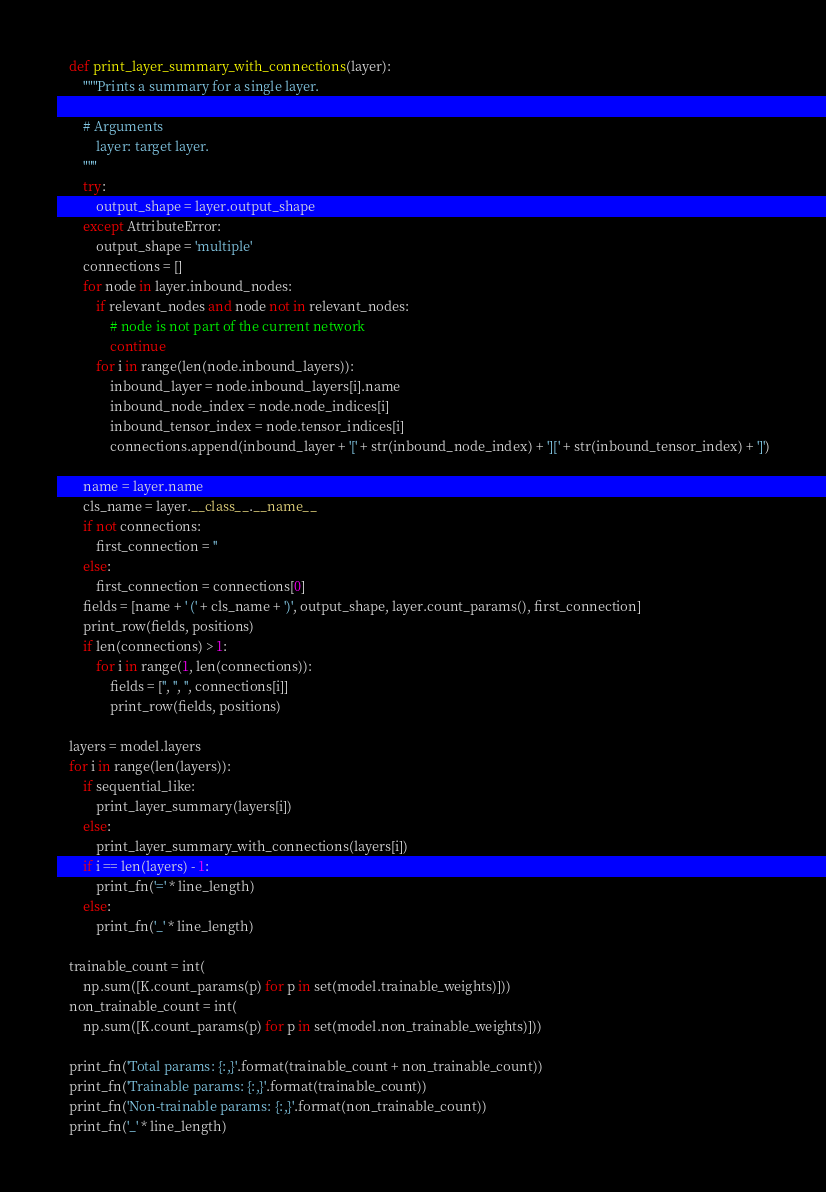<code> <loc_0><loc_0><loc_500><loc_500><_Python_>
    def print_layer_summary_with_connections(layer):
        """Prints a summary for a single layer.

        # Arguments
            layer: target layer.
        """
        try:
            output_shape = layer.output_shape
        except AttributeError:
            output_shape = 'multiple'
        connections = []
        for node in layer.inbound_nodes:
            if relevant_nodes and node not in relevant_nodes:
                # node is not part of the current network
                continue
            for i in range(len(node.inbound_layers)):
                inbound_layer = node.inbound_layers[i].name
                inbound_node_index = node.node_indices[i]
                inbound_tensor_index = node.tensor_indices[i]
                connections.append(inbound_layer + '[' + str(inbound_node_index) + '][' + str(inbound_tensor_index) + ']')

        name = layer.name
        cls_name = layer.__class__.__name__
        if not connections:
            first_connection = ''
        else:
            first_connection = connections[0]
        fields = [name + ' (' + cls_name + ')', output_shape, layer.count_params(), first_connection]
        print_row(fields, positions)
        if len(connections) > 1:
            for i in range(1, len(connections)):
                fields = ['', '', '', connections[i]]
                print_row(fields, positions)

    layers = model.layers
    for i in range(len(layers)):
        if sequential_like:
            print_layer_summary(layers[i])
        else:
            print_layer_summary_with_connections(layers[i])
        if i == len(layers) - 1:
            print_fn('=' * line_length)
        else:
            print_fn('_' * line_length)

    trainable_count = int(
        np.sum([K.count_params(p) for p in set(model.trainable_weights)]))
    non_trainable_count = int(
        np.sum([K.count_params(p) for p in set(model.non_trainable_weights)]))

    print_fn('Total params: {:,}'.format(trainable_count + non_trainable_count))
    print_fn('Trainable params: {:,}'.format(trainable_count))
    print_fn('Non-trainable params: {:,}'.format(non_trainable_count))
    print_fn('_' * line_length)

</code> 